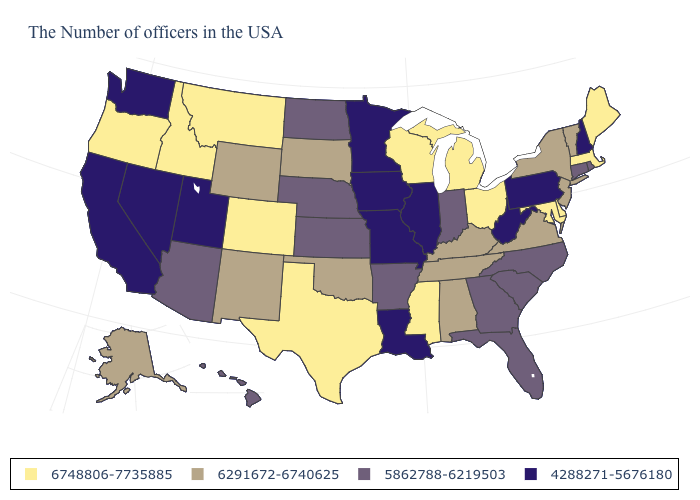Name the states that have a value in the range 4288271-5676180?
Keep it brief. New Hampshire, Pennsylvania, West Virginia, Illinois, Louisiana, Missouri, Minnesota, Iowa, Utah, Nevada, California, Washington. What is the value of Ohio?
Short answer required. 6748806-7735885. What is the value of Washington?
Concise answer only. 4288271-5676180. Which states have the highest value in the USA?
Answer briefly. Maine, Massachusetts, Delaware, Maryland, Ohio, Michigan, Wisconsin, Mississippi, Texas, Colorado, Montana, Idaho, Oregon. Name the states that have a value in the range 6748806-7735885?
Write a very short answer. Maine, Massachusetts, Delaware, Maryland, Ohio, Michigan, Wisconsin, Mississippi, Texas, Colorado, Montana, Idaho, Oregon. How many symbols are there in the legend?
Keep it brief. 4. What is the value of Wyoming?
Short answer required. 6291672-6740625. Which states have the lowest value in the South?
Short answer required. West Virginia, Louisiana. Does the first symbol in the legend represent the smallest category?
Quick response, please. No. How many symbols are there in the legend?
Concise answer only. 4. Among the states that border Pennsylvania , which have the highest value?
Give a very brief answer. Delaware, Maryland, Ohio. What is the value of Minnesota?
Quick response, please. 4288271-5676180. Does Iowa have the lowest value in the USA?
Write a very short answer. Yes. Does Michigan have the highest value in the USA?
Quick response, please. Yes. What is the highest value in the USA?
Write a very short answer. 6748806-7735885. 